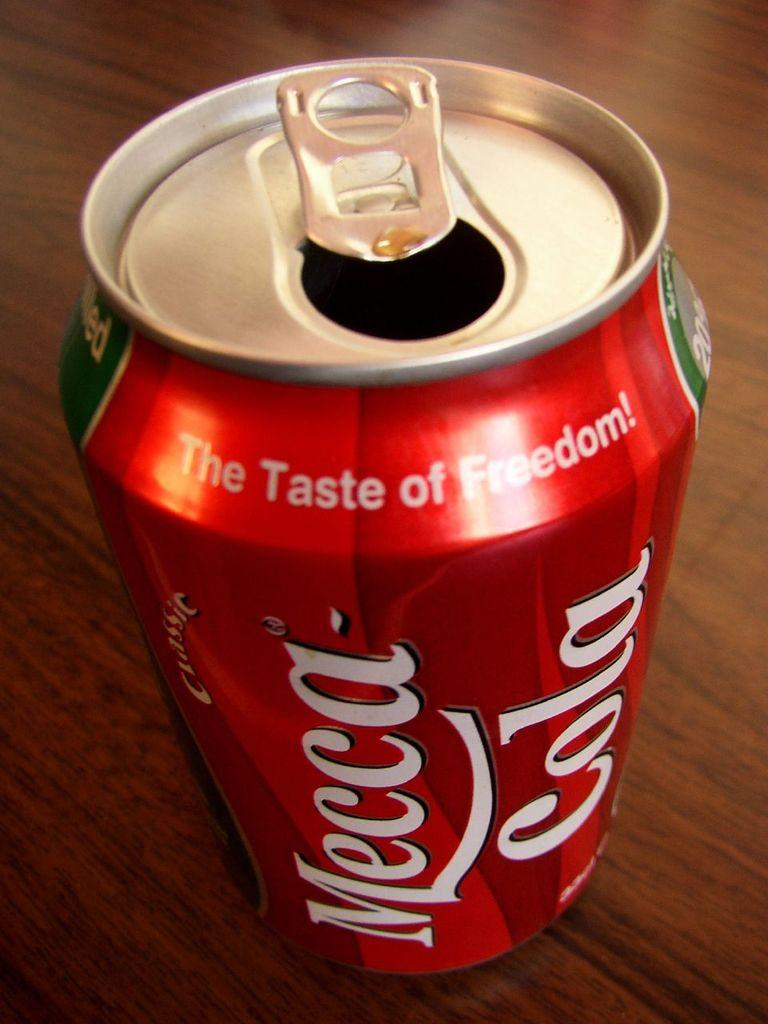<image>
Describe the image concisely. Mecca cola can that is red and sitting on a table 